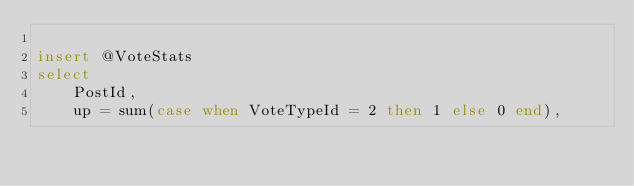<code> <loc_0><loc_0><loc_500><loc_500><_SQL_>
insert @VoteStats
select
    PostId, 
    up = sum(case when VoteTypeId = 2 then 1 else 0 end), </code> 